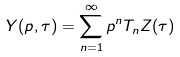<formula> <loc_0><loc_0><loc_500><loc_500>Y ( p , \tau ) = \sum _ { n = 1 } ^ { \infty } p ^ { n } T _ { n } Z ( \tau )</formula> 